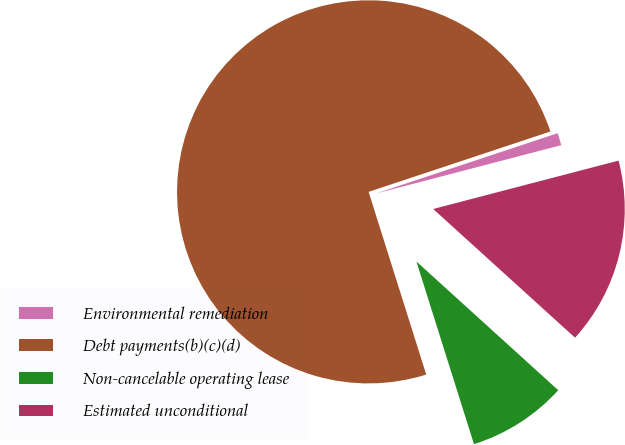Convert chart to OTSL. <chart><loc_0><loc_0><loc_500><loc_500><pie_chart><fcel>Environmental remediation<fcel>Debt payments(b)(c)(d)<fcel>Non-cancelable operating lease<fcel>Estimated unconditional<nl><fcel>1.04%<fcel>74.76%<fcel>8.41%<fcel>15.79%<nl></chart> 